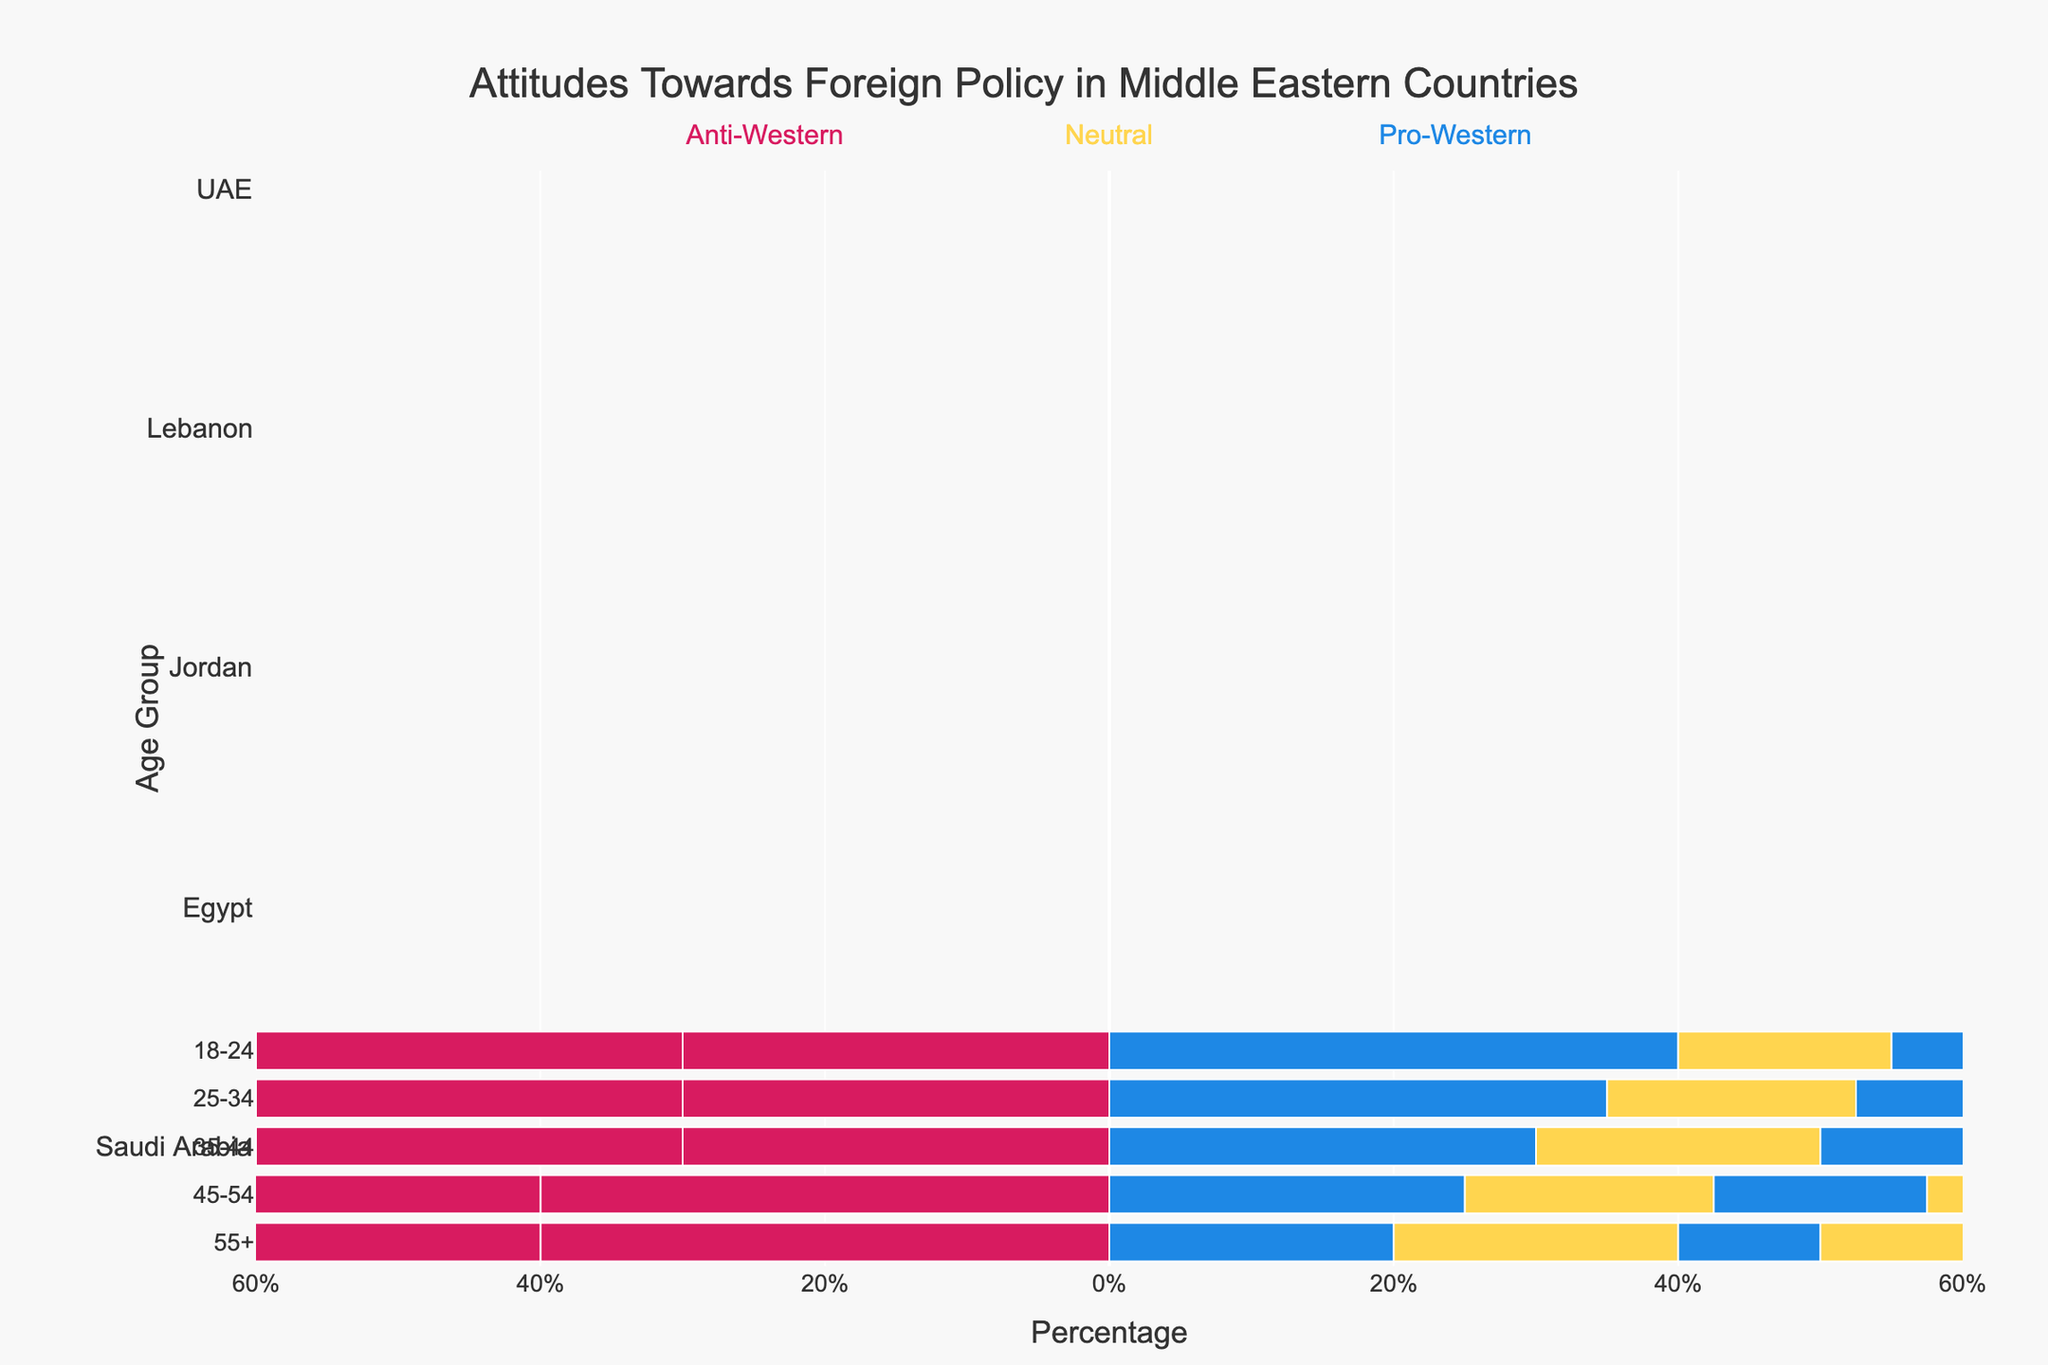Which country has the highest percentage of Pro-Western attitudes in the 18-24 age group? Look at the bars corresponding to the Pro-Western attitudes for the 18-24 age group across all countries. The UAE has a Pro-Western bar that reaches 50%, which is the highest among all countries for that age group.
Answer: UAE Among the 45-54 age group, which country shows the highest percentage of Anti-Western attitudes? Check the Anti-Western bars for the 45-54 age group in each country. Egypt has the highest percentage with an Anti-Western bar reaching 40%.
Answer: Egypt Compare the level of Neutral attitudes between Lebanon and Egypt for the 35-44 age group. Which country shows greater neutrality? Look at the Neutral bars for the 35-44 age group in Lebanon and Egypt. Lebanon's Neutral bar is at 35% while Egypt's is at 50%. Thus, Egypt shows greater neutrality.
Answer: Egypt What is the total percentage of Neutral attitudes among all age groups for Saudi Arabia? Add the Neutral percentages for all age groups in Saudi Arabia: 30% (18-24) + 35% (25-34) + 40% (35-44) + 35% (45-54) + 40% (55+). This gives a total of 180%.
Answer: 180% Which age group in Jordan has the least amount of Pro-Western attitudes? Observe the Pro-Western bars for all age groups in Jordan. The 55+ age group has the shortest Pro-Western bar at 15%.
Answer: 55+ Is the 18-24 age group more Neutral or Anti-Western in Egypt? Compare the Neutral (40%) and Anti-Western (30%) bars for the 18-24 age group in Egypt. The Neutral bar is longer, indicating they are more Neutral.
Answer: Neutral Calculate the average percentage of Pro-Western attitudes across all age groups in Lebanon. Add the Pro-Western percentages for all age groups in Lebanon: 45% (18-24) + 40% (25-34) + 35% (35-44) + 30% (45-54) + 25% (55+). The total is 175%. Divide by 5 (number of age groups), resulting in an average of 35%.
Answer: 35% Which country has the smallest variation in Pro-Western attitudes across different age groups? Determine the range of Pro-Western percentages for each country. Saudi Arabia has a range from 20% to 40%, Egypt from 10% to 30%, Jordan from 15% to 35%, Lebanon from 25% to 45%, and UAE from 30% to 50%. Saudi Arabia has the smallest range (20%).
Answer: Saudi Arabia For the 55+ age group, compare the Neutral attitudes in Saudi Arabia and Jordan. Which country shows higher neutrality? Look at the Neutral bars for the 55+ age group in both countries. Both Saudi Arabia and Jordan have Neutral bars at 40%, indicating they show equal neutrality.
Answer: Equal 